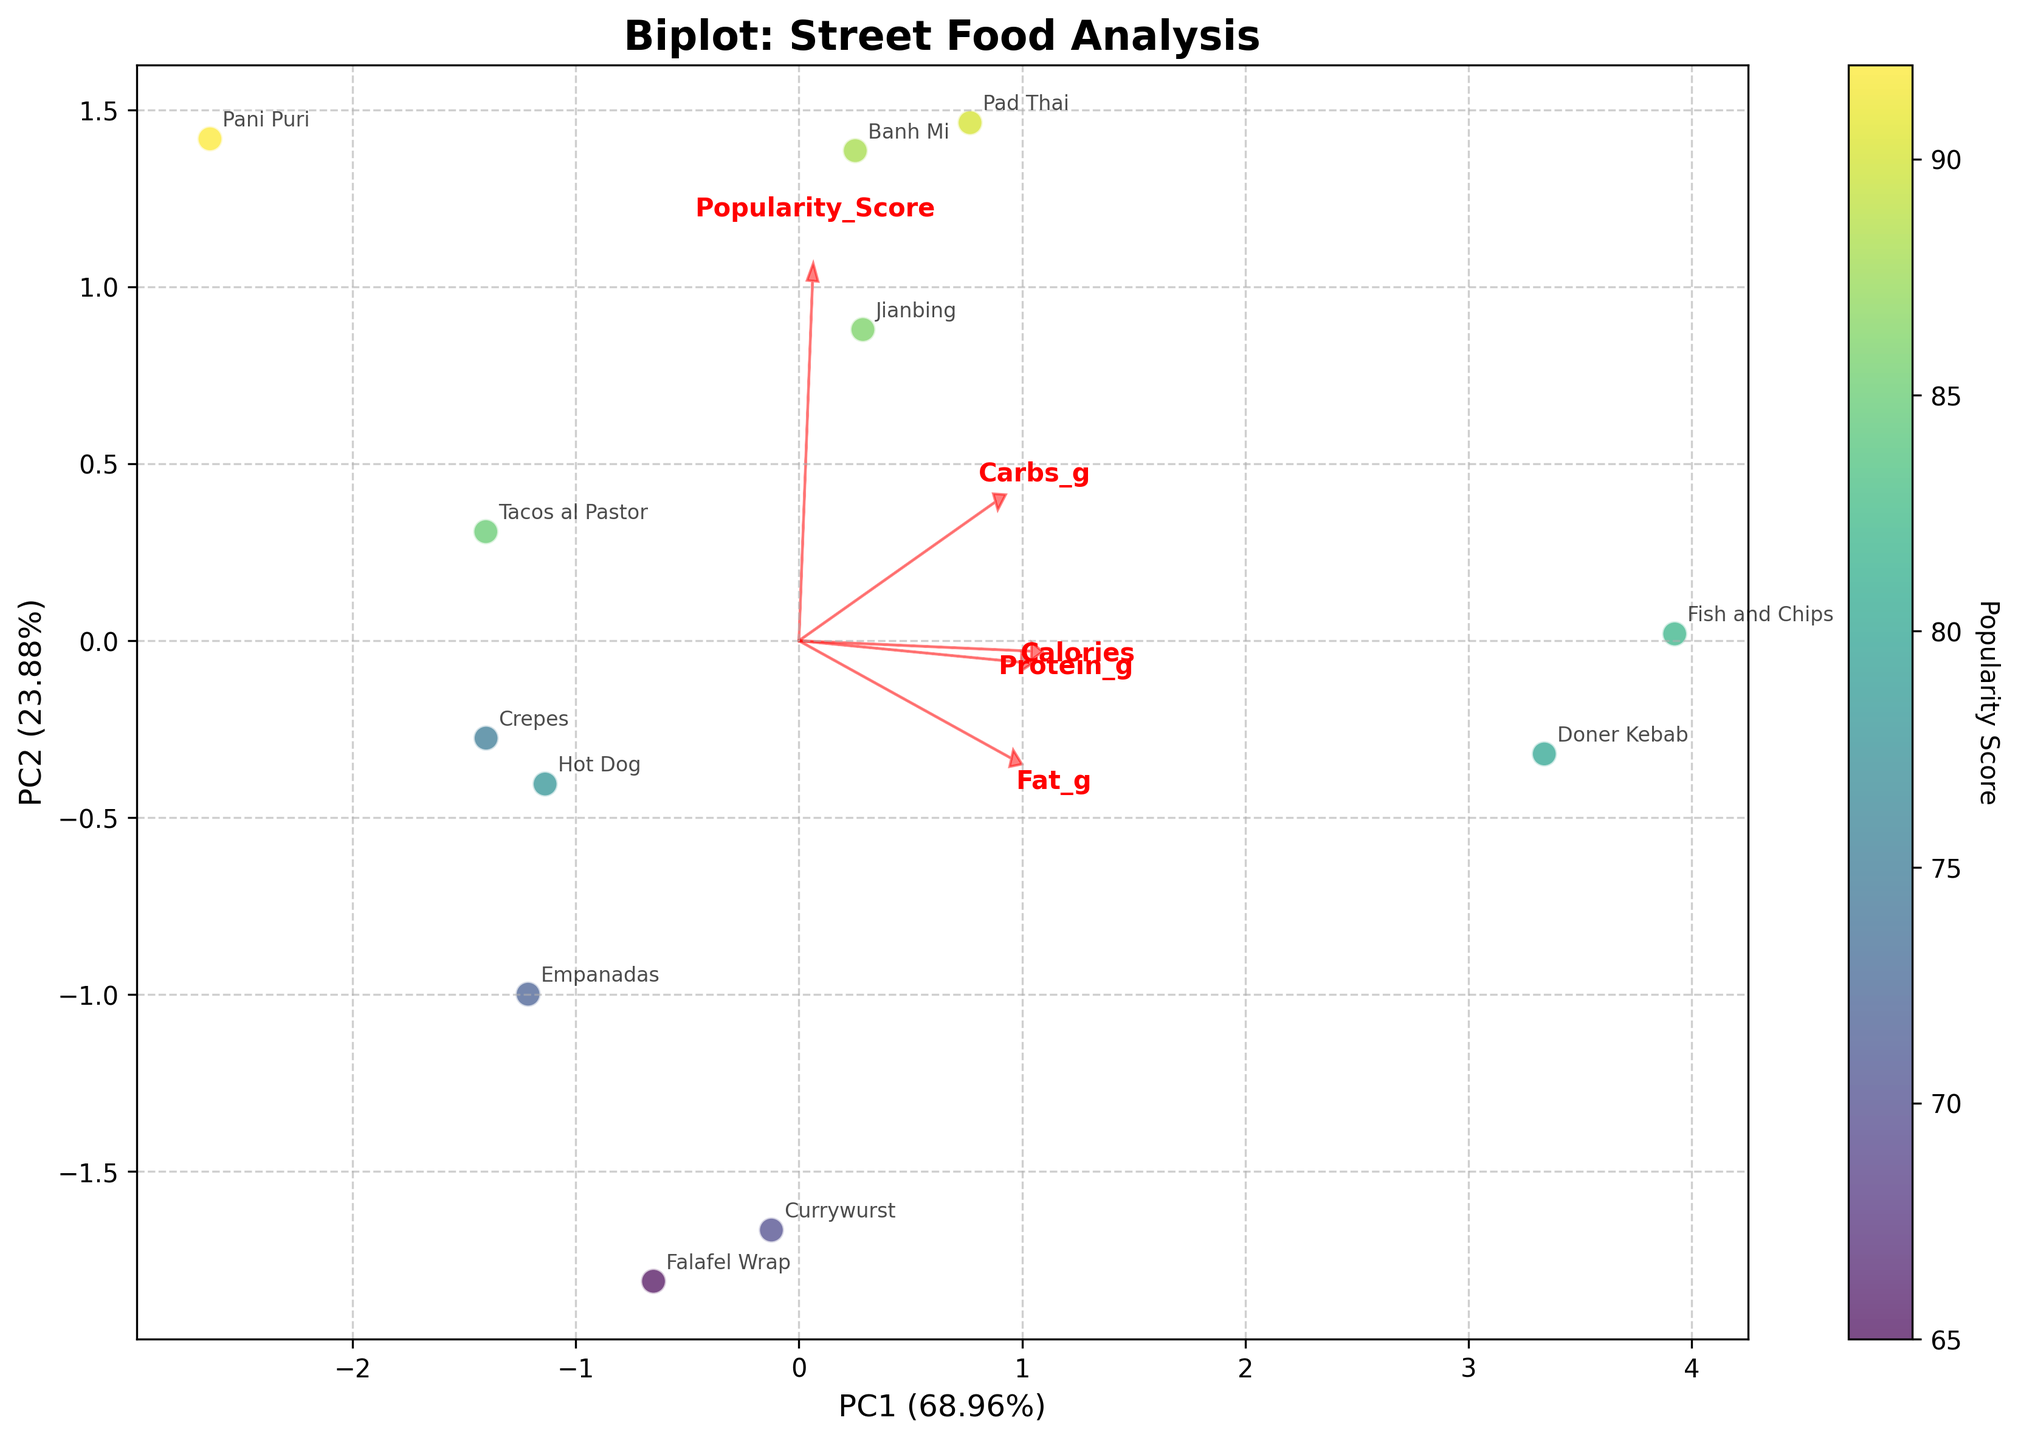What's the title of the biplot? The title is located at the top of the plot and usually indicates what is being analyzed. In this case, it says "Biplot: Street Food Analysis".
Answer: Biplot: Street Food Analysis How many street food items are represented in the biplot? To determine this, count the number of data points (or text labels) on the plot, each representing a street food item. There are 12 street food items shown.
Answer: 12 Which street food item has the highest popularity score? Look for the data point with the highest point on the color bar, which indicates the popularity score. The Pani Puri has the highest popularity score as it is associated with a score of 92.
Answer: Pani Puri Which principal component (PC) explains more of the variance in the data? Look at the labels of the axes to see the percentage of variance explained by each principal component. PC1 explains a higher percentage of the variance (approximately 40%).
Answer: PC1 Which nutrient has the highest loading on PC1? Check the direction and length of the red arrows on the biplot. The nutrient with the arrow pointing most along the PC1 axis and with the greatest length represents the highest loading. "Calories" has the highest loading on PC1.
Answer: Calories How does the loading of carbohydrates compare to that of fat? Compare the lengths and directions of the arrows representing "Carbs_g" and "Fat_g". "Carbs_g" has a higher loading on both PCs compared to "Fat_g" since its arrow is longer and more aligned with both axes.
Answer: Carbs_g has a higher loading than Fat_g Which city has the food item with the highest calories? Look for the data point associated with the highest calorie value. According to the provided data, "Fish and Chips" from London has the highest calorie count.
Answer: London Are there any food items that are notably high in both protein and calories? Check the placement of the data points in relation to the red arrows for "Protein_g" and "Calories". "Fish and Chips" and "Doner Kebab" are high in both protein and calories, positioned in the direction of both arrows.
Answer: Fish and Chips, Doner Kebab Which two cities' food items are positioned furthest apart on the biplot? Look for the two points that are the most distant from each other on the plot. "Pad Thai" from Bangkok and "Falafel Wrap" from Cairo are positioned furthest apart.
Answer: Bangkok and Cairo What is the direction of the arrow representing "Popularity_Score" and how does it orient in relation to PC1 and PC2? Observe the direction of the red arrow labeled "Popularity_Score". It primarily points in the direction of PC1 (to the right), indicating a positive correlation with the first principal component.
Answer: It points towards the right, aligned with PC1 